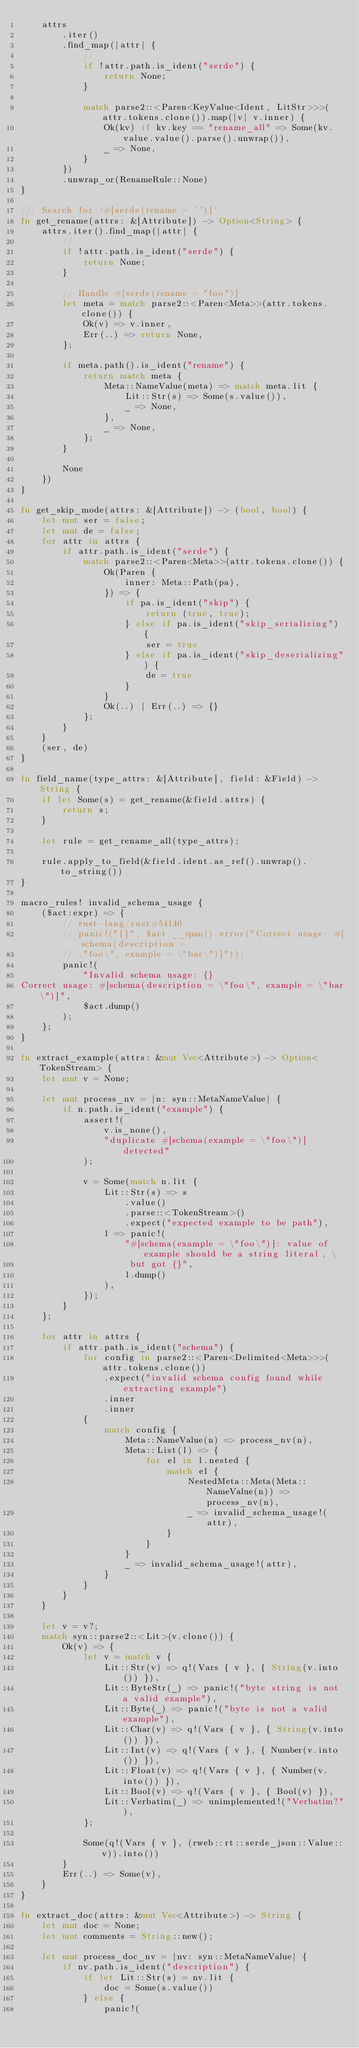<code> <loc_0><loc_0><loc_500><loc_500><_Rust_>    attrs
        .iter()
        .find_map(|attr| {
            //
            if !attr.path.is_ident("serde") {
                return None;
            }

            match parse2::<Paren<KeyValue<Ident, LitStr>>>(attr.tokens.clone()).map(|v| v.inner) {
                Ok(kv) if kv.key == "rename_all" => Some(kv.value.value().parse().unwrap()),
                _ => None,
            }
        })
        .unwrap_or(RenameRule::None)
}

/// Search for `#[serde(rename = '')]`
fn get_rename(attrs: &[Attribute]) -> Option<String> {
    attrs.iter().find_map(|attr| {
        //
        if !attr.path.is_ident("serde") {
            return None;
        }

        // Handle #[serde(rename = "foo")]
        let meta = match parse2::<Paren<Meta>>(attr.tokens.clone()) {
            Ok(v) => v.inner,
            Err(..) => return None,
        };

        if meta.path().is_ident("rename") {
            return match meta {
                Meta::NameValue(meta) => match meta.lit {
                    Lit::Str(s) => Some(s.value()),
                    _ => None,
                },
                _ => None,
            };
        }

        None
    })
}

fn get_skip_mode(attrs: &[Attribute]) -> (bool, bool) {
    let mut ser = false;
    let mut de = false;
    for attr in attrs {
        if attr.path.is_ident("serde") {
            match parse2::<Paren<Meta>>(attr.tokens.clone()) {
                Ok(Paren {
                    inner: Meta::Path(pa),
                }) => {
                    if pa.is_ident("skip") {
                        return (true, true);
                    } else if pa.is_ident("skip_serializing") {
                        ser = true
                    } else if pa.is_ident("skip_deserializing") {
                        de = true
                    }
                }
                Ok(..) | Err(..) => {}
            };
        }
    }
    (ser, de)
}

fn field_name(type_attrs: &[Attribute], field: &Field) -> String {
    if let Some(s) = get_rename(&field.attrs) {
        return s;
    }

    let rule = get_rename_all(type_attrs);

    rule.apply_to_field(&field.ident.as_ref().unwrap().to_string())
}

macro_rules! invalid_schema_usage {
    ($act:expr) => {
        // rust-lang/rust#54140
        // panic!("{}", $act.__span().error("Correct usage: #[schema(description =
        // \"foo\", example = \"bar\")]"));
        panic!(
            "Invalid schema usage: {}
Correct usage: #[schema(description = \"foo\", example = \"bar\")]",
            $act.dump()
        );
    };
}

fn extract_example(attrs: &mut Vec<Attribute>) -> Option<TokenStream> {
    let mut v = None;

    let mut process_nv = |n: syn::MetaNameValue| {
        if n.path.is_ident("example") {
            assert!(
                v.is_none(),
                "duplicate #[schema(example = \"foo\")] detected"
            );

            v = Some(match n.lit {
                Lit::Str(s) => s
                    .value()
                    .parse::<TokenStream>()
                    .expect("expected example to be path"),
                l => panic!(
                    "#[schema(example = \"foo\")]: value of example should be a string literal, \
                     but got {}",
                    l.dump()
                ),
            });
        }
    };

    for attr in attrs {
        if attr.path.is_ident("schema") {
            for config in parse2::<Paren<Delimited<Meta>>>(attr.tokens.clone())
                .expect("invalid schema config found while extracting example")
                .inner
                .inner
            {
                match config {
                    Meta::NameValue(n) => process_nv(n),
                    Meta::List(l) => {
                        for el in l.nested {
                            match el {
                                NestedMeta::Meta(Meta::NameValue(n)) => process_nv(n),
                                _ => invalid_schema_usage!(attr),
                            }
                        }
                    }
                    _ => invalid_schema_usage!(attr),
                }
            }
        }
    }

    let v = v?;
    match syn::parse2::<Lit>(v.clone()) {
        Ok(v) => {
            let v = match v {
                Lit::Str(v) => q!(Vars { v }, { String(v.into()) }),
                Lit::ByteStr(_) => panic!("byte string is not a valid example"),
                Lit::Byte(_) => panic!("byte is not a valid example"),
                Lit::Char(v) => q!(Vars { v }, { String(v.into()) }),
                Lit::Int(v) => q!(Vars { v }, { Number(v.into()) }),
                Lit::Float(v) => q!(Vars { v }, { Number(v.into()) }),
                Lit::Bool(v) => q!(Vars { v }, { Bool(v) }),
                Lit::Verbatim(_) => unimplemented!("Verbatim?"),
            };

            Some(q!(Vars { v }, (rweb::rt::serde_json::Value::v)).into())
        }
        Err(..) => Some(v),
    }
}

fn extract_doc(attrs: &mut Vec<Attribute>) -> String {
    let mut doc = None;
    let mut comments = String::new();

    let mut process_doc_nv = |nv: syn::MetaNameValue| {
        if nv.path.is_ident("description") {
            if let Lit::Str(s) = nv.lit {
                doc = Some(s.value())
            } else {
                panic!(</code> 